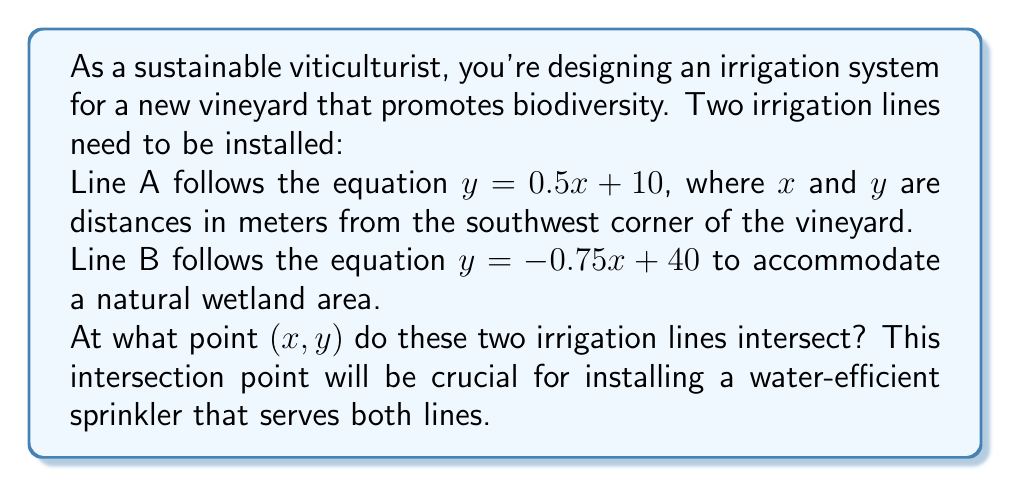Can you solve this math problem? To find the intersection point of two lines, we need to solve the system of equations:

$$\begin{cases}
y = 0.5x + 10 \\
y = -0.75x + 40
\end{cases}$$

Since both equations are equal to $y$, we can set them equal to each other:

$$0.5x + 10 = -0.75x + 40$$

Now, let's solve for $x$:

1) First, subtract 10 from both sides:
   $$0.5x = -0.75x + 30$$

2) Add $0.75x$ to both sides:
   $$1.25x = 30$$

3) Divide both sides by 1.25:
   $$x = 24$$

Now that we know $x = 24$, we can substitute this value into either of the original equations to find $y$. Let's use the equation for Line A:

$$y = 0.5x + 10$$
$$y = 0.5(24) + 10$$
$$y = 12 + 10 = 22$$

Therefore, the intersection point is (24, 22).
Answer: The irrigation lines intersect at the point (24, 22) meters from the southwest corner of the vineyard. 